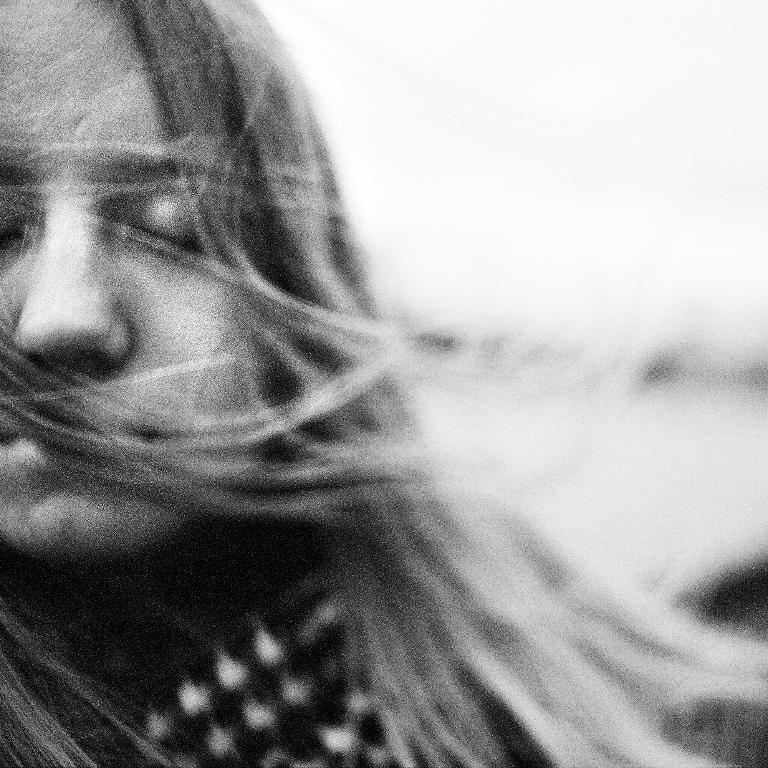Who is the main subject in the image? There is a woman in the image. What is the woman wearing? The woman is wearing clothes. What color is the background of the image? The background of the image is white. How many kittens are playing in the quicksand in the image? There are no kittens or quicksand present in the image; it features a woman with a white background. 